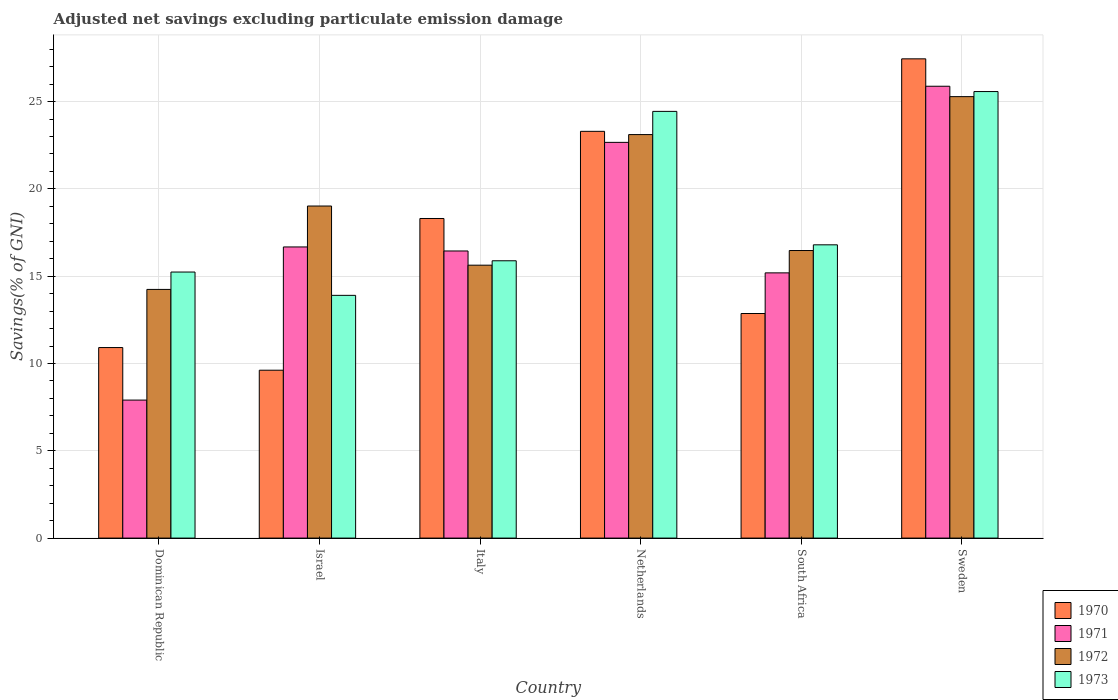How many different coloured bars are there?
Offer a very short reply. 4. Are the number of bars per tick equal to the number of legend labels?
Provide a short and direct response. Yes. How many bars are there on the 6th tick from the left?
Make the answer very short. 4. How many bars are there on the 3rd tick from the right?
Provide a short and direct response. 4. What is the adjusted net savings in 1971 in Italy?
Make the answer very short. 16.44. Across all countries, what is the maximum adjusted net savings in 1971?
Provide a succinct answer. 25.88. Across all countries, what is the minimum adjusted net savings in 1973?
Provide a short and direct response. 13.9. In which country was the adjusted net savings in 1971 minimum?
Offer a very short reply. Dominican Republic. What is the total adjusted net savings in 1970 in the graph?
Give a very brief answer. 102.44. What is the difference between the adjusted net savings in 1972 in Israel and that in Netherlands?
Provide a short and direct response. -4.09. What is the difference between the adjusted net savings in 1970 in South Africa and the adjusted net savings in 1971 in Italy?
Make the answer very short. -3.58. What is the average adjusted net savings in 1973 per country?
Provide a short and direct response. 18.64. What is the difference between the adjusted net savings of/in 1970 and adjusted net savings of/in 1973 in Israel?
Keep it short and to the point. -4.29. What is the ratio of the adjusted net savings in 1973 in Israel to that in Sweden?
Your answer should be very brief. 0.54. Is the adjusted net savings in 1973 in Netherlands less than that in Sweden?
Your answer should be compact. Yes. What is the difference between the highest and the second highest adjusted net savings in 1973?
Your response must be concise. -1.14. What is the difference between the highest and the lowest adjusted net savings in 1972?
Make the answer very short. 11.04. What does the 4th bar from the left in Israel represents?
Your answer should be very brief. 1973. What does the 3rd bar from the right in Netherlands represents?
Your answer should be very brief. 1971. How many bars are there?
Your answer should be very brief. 24. How many countries are there in the graph?
Provide a succinct answer. 6. Does the graph contain grids?
Offer a very short reply. Yes. How many legend labels are there?
Offer a very short reply. 4. What is the title of the graph?
Your answer should be compact. Adjusted net savings excluding particulate emission damage. What is the label or title of the Y-axis?
Your answer should be very brief. Savings(% of GNI). What is the Savings(% of GNI) in 1970 in Dominican Republic?
Ensure brevity in your answer.  10.91. What is the Savings(% of GNI) in 1971 in Dominican Republic?
Provide a succinct answer. 7.9. What is the Savings(% of GNI) in 1972 in Dominican Republic?
Provide a succinct answer. 14.24. What is the Savings(% of GNI) of 1973 in Dominican Republic?
Give a very brief answer. 15.24. What is the Savings(% of GNI) of 1970 in Israel?
Make the answer very short. 9.61. What is the Savings(% of GNI) in 1971 in Israel?
Your answer should be very brief. 16.67. What is the Savings(% of GNI) in 1972 in Israel?
Offer a terse response. 19.02. What is the Savings(% of GNI) in 1973 in Israel?
Give a very brief answer. 13.9. What is the Savings(% of GNI) in 1970 in Italy?
Your answer should be very brief. 18.3. What is the Savings(% of GNI) of 1971 in Italy?
Keep it short and to the point. 16.44. What is the Savings(% of GNI) of 1972 in Italy?
Provide a succinct answer. 15.63. What is the Savings(% of GNI) in 1973 in Italy?
Make the answer very short. 15.88. What is the Savings(% of GNI) of 1970 in Netherlands?
Give a very brief answer. 23.3. What is the Savings(% of GNI) in 1971 in Netherlands?
Make the answer very short. 22.66. What is the Savings(% of GNI) in 1972 in Netherlands?
Ensure brevity in your answer.  23.11. What is the Savings(% of GNI) in 1973 in Netherlands?
Your response must be concise. 24.44. What is the Savings(% of GNI) in 1970 in South Africa?
Provide a succinct answer. 12.86. What is the Savings(% of GNI) in 1971 in South Africa?
Keep it short and to the point. 15.19. What is the Savings(% of GNI) of 1972 in South Africa?
Give a very brief answer. 16.47. What is the Savings(% of GNI) in 1973 in South Africa?
Ensure brevity in your answer.  16.8. What is the Savings(% of GNI) in 1970 in Sweden?
Make the answer very short. 27.45. What is the Savings(% of GNI) in 1971 in Sweden?
Offer a terse response. 25.88. What is the Savings(% of GNI) in 1972 in Sweden?
Ensure brevity in your answer.  25.28. What is the Savings(% of GNI) in 1973 in Sweden?
Your answer should be very brief. 25.57. Across all countries, what is the maximum Savings(% of GNI) of 1970?
Make the answer very short. 27.45. Across all countries, what is the maximum Savings(% of GNI) in 1971?
Give a very brief answer. 25.88. Across all countries, what is the maximum Savings(% of GNI) in 1972?
Give a very brief answer. 25.28. Across all countries, what is the maximum Savings(% of GNI) of 1973?
Provide a short and direct response. 25.57. Across all countries, what is the minimum Savings(% of GNI) in 1970?
Give a very brief answer. 9.61. Across all countries, what is the minimum Savings(% of GNI) of 1971?
Your answer should be very brief. 7.9. Across all countries, what is the minimum Savings(% of GNI) in 1972?
Provide a short and direct response. 14.24. Across all countries, what is the minimum Savings(% of GNI) in 1973?
Your answer should be compact. 13.9. What is the total Savings(% of GNI) of 1970 in the graph?
Keep it short and to the point. 102.44. What is the total Savings(% of GNI) in 1971 in the graph?
Provide a short and direct response. 104.75. What is the total Savings(% of GNI) of 1972 in the graph?
Make the answer very short. 113.75. What is the total Savings(% of GNI) in 1973 in the graph?
Your answer should be compact. 111.83. What is the difference between the Savings(% of GNI) in 1970 in Dominican Republic and that in Israel?
Give a very brief answer. 1.3. What is the difference between the Savings(% of GNI) in 1971 in Dominican Republic and that in Israel?
Offer a very short reply. -8.77. What is the difference between the Savings(% of GNI) in 1972 in Dominican Republic and that in Israel?
Give a very brief answer. -4.78. What is the difference between the Savings(% of GNI) in 1973 in Dominican Republic and that in Israel?
Offer a very short reply. 1.34. What is the difference between the Savings(% of GNI) in 1970 in Dominican Republic and that in Italy?
Give a very brief answer. -7.39. What is the difference between the Savings(% of GNI) in 1971 in Dominican Republic and that in Italy?
Give a very brief answer. -8.54. What is the difference between the Savings(% of GNI) in 1972 in Dominican Republic and that in Italy?
Your response must be concise. -1.39. What is the difference between the Savings(% of GNI) of 1973 in Dominican Republic and that in Italy?
Offer a very short reply. -0.65. What is the difference between the Savings(% of GNI) in 1970 in Dominican Republic and that in Netherlands?
Your answer should be very brief. -12.38. What is the difference between the Savings(% of GNI) of 1971 in Dominican Republic and that in Netherlands?
Offer a very short reply. -14.76. What is the difference between the Savings(% of GNI) in 1972 in Dominican Republic and that in Netherlands?
Your answer should be compact. -8.87. What is the difference between the Savings(% of GNI) of 1973 in Dominican Republic and that in Netherlands?
Offer a terse response. -9.2. What is the difference between the Savings(% of GNI) of 1970 in Dominican Republic and that in South Africa?
Your answer should be compact. -1.95. What is the difference between the Savings(% of GNI) in 1971 in Dominican Republic and that in South Africa?
Provide a short and direct response. -7.29. What is the difference between the Savings(% of GNI) in 1972 in Dominican Republic and that in South Africa?
Offer a very short reply. -2.23. What is the difference between the Savings(% of GNI) in 1973 in Dominican Republic and that in South Africa?
Your response must be concise. -1.56. What is the difference between the Savings(% of GNI) in 1970 in Dominican Republic and that in Sweden?
Make the answer very short. -16.54. What is the difference between the Savings(% of GNI) in 1971 in Dominican Republic and that in Sweden?
Provide a short and direct response. -17.97. What is the difference between the Savings(% of GNI) of 1972 in Dominican Republic and that in Sweden?
Offer a very short reply. -11.04. What is the difference between the Savings(% of GNI) in 1973 in Dominican Republic and that in Sweden?
Provide a succinct answer. -10.34. What is the difference between the Savings(% of GNI) of 1970 in Israel and that in Italy?
Your answer should be very brief. -8.69. What is the difference between the Savings(% of GNI) of 1971 in Israel and that in Italy?
Your answer should be very brief. 0.23. What is the difference between the Savings(% of GNI) of 1972 in Israel and that in Italy?
Your answer should be very brief. 3.39. What is the difference between the Savings(% of GNI) in 1973 in Israel and that in Italy?
Offer a very short reply. -1.98. What is the difference between the Savings(% of GNI) of 1970 in Israel and that in Netherlands?
Offer a terse response. -13.68. What is the difference between the Savings(% of GNI) of 1971 in Israel and that in Netherlands?
Offer a terse response. -5.99. What is the difference between the Savings(% of GNI) of 1972 in Israel and that in Netherlands?
Your response must be concise. -4.09. What is the difference between the Savings(% of GNI) in 1973 in Israel and that in Netherlands?
Your response must be concise. -10.54. What is the difference between the Savings(% of GNI) of 1970 in Israel and that in South Africa?
Provide a short and direct response. -3.25. What is the difference between the Savings(% of GNI) of 1971 in Israel and that in South Africa?
Ensure brevity in your answer.  1.48. What is the difference between the Savings(% of GNI) in 1972 in Israel and that in South Africa?
Ensure brevity in your answer.  2.55. What is the difference between the Savings(% of GNI) in 1973 in Israel and that in South Africa?
Give a very brief answer. -2.89. What is the difference between the Savings(% of GNI) in 1970 in Israel and that in Sweden?
Keep it short and to the point. -17.83. What is the difference between the Savings(% of GNI) in 1971 in Israel and that in Sweden?
Offer a terse response. -9.2. What is the difference between the Savings(% of GNI) of 1972 in Israel and that in Sweden?
Your answer should be compact. -6.27. What is the difference between the Savings(% of GNI) in 1973 in Israel and that in Sweden?
Give a very brief answer. -11.67. What is the difference between the Savings(% of GNI) in 1970 in Italy and that in Netherlands?
Make the answer very short. -4.99. What is the difference between the Savings(% of GNI) in 1971 in Italy and that in Netherlands?
Ensure brevity in your answer.  -6.22. What is the difference between the Savings(% of GNI) of 1972 in Italy and that in Netherlands?
Ensure brevity in your answer.  -7.48. What is the difference between the Savings(% of GNI) in 1973 in Italy and that in Netherlands?
Your answer should be very brief. -8.56. What is the difference between the Savings(% of GNI) in 1970 in Italy and that in South Africa?
Keep it short and to the point. 5.44. What is the difference between the Savings(% of GNI) in 1971 in Italy and that in South Africa?
Keep it short and to the point. 1.25. What is the difference between the Savings(% of GNI) of 1972 in Italy and that in South Africa?
Your response must be concise. -0.84. What is the difference between the Savings(% of GNI) of 1973 in Italy and that in South Africa?
Your answer should be very brief. -0.91. What is the difference between the Savings(% of GNI) in 1970 in Italy and that in Sweden?
Ensure brevity in your answer.  -9.14. What is the difference between the Savings(% of GNI) in 1971 in Italy and that in Sweden?
Your answer should be compact. -9.43. What is the difference between the Savings(% of GNI) of 1972 in Italy and that in Sweden?
Your answer should be compact. -9.65. What is the difference between the Savings(% of GNI) in 1973 in Italy and that in Sweden?
Your response must be concise. -9.69. What is the difference between the Savings(% of GNI) in 1970 in Netherlands and that in South Africa?
Keep it short and to the point. 10.43. What is the difference between the Savings(% of GNI) in 1971 in Netherlands and that in South Africa?
Make the answer very short. 7.47. What is the difference between the Savings(% of GNI) of 1972 in Netherlands and that in South Africa?
Make the answer very short. 6.64. What is the difference between the Savings(% of GNI) of 1973 in Netherlands and that in South Africa?
Make the answer very short. 7.64. What is the difference between the Savings(% of GNI) in 1970 in Netherlands and that in Sweden?
Keep it short and to the point. -4.15. What is the difference between the Savings(% of GNI) in 1971 in Netherlands and that in Sweden?
Make the answer very short. -3.21. What is the difference between the Savings(% of GNI) of 1972 in Netherlands and that in Sweden?
Your answer should be very brief. -2.17. What is the difference between the Savings(% of GNI) in 1973 in Netherlands and that in Sweden?
Ensure brevity in your answer.  -1.14. What is the difference between the Savings(% of GNI) in 1970 in South Africa and that in Sweden?
Offer a very short reply. -14.59. What is the difference between the Savings(% of GNI) of 1971 in South Africa and that in Sweden?
Provide a short and direct response. -10.69. What is the difference between the Savings(% of GNI) in 1972 in South Africa and that in Sweden?
Give a very brief answer. -8.81. What is the difference between the Savings(% of GNI) in 1973 in South Africa and that in Sweden?
Your answer should be very brief. -8.78. What is the difference between the Savings(% of GNI) in 1970 in Dominican Republic and the Savings(% of GNI) in 1971 in Israel?
Your answer should be very brief. -5.76. What is the difference between the Savings(% of GNI) in 1970 in Dominican Republic and the Savings(% of GNI) in 1972 in Israel?
Offer a very short reply. -8.11. What is the difference between the Savings(% of GNI) of 1970 in Dominican Republic and the Savings(% of GNI) of 1973 in Israel?
Provide a short and direct response. -2.99. What is the difference between the Savings(% of GNI) in 1971 in Dominican Republic and the Savings(% of GNI) in 1972 in Israel?
Make the answer very short. -11.11. What is the difference between the Savings(% of GNI) of 1971 in Dominican Republic and the Savings(% of GNI) of 1973 in Israel?
Keep it short and to the point. -6. What is the difference between the Savings(% of GNI) of 1972 in Dominican Republic and the Savings(% of GNI) of 1973 in Israel?
Your answer should be very brief. 0.34. What is the difference between the Savings(% of GNI) of 1970 in Dominican Republic and the Savings(% of GNI) of 1971 in Italy?
Keep it short and to the point. -5.53. What is the difference between the Savings(% of GNI) of 1970 in Dominican Republic and the Savings(% of GNI) of 1972 in Italy?
Keep it short and to the point. -4.72. What is the difference between the Savings(% of GNI) of 1970 in Dominican Republic and the Savings(% of GNI) of 1973 in Italy?
Ensure brevity in your answer.  -4.97. What is the difference between the Savings(% of GNI) of 1971 in Dominican Republic and the Savings(% of GNI) of 1972 in Italy?
Provide a succinct answer. -7.73. What is the difference between the Savings(% of GNI) in 1971 in Dominican Republic and the Savings(% of GNI) in 1973 in Italy?
Ensure brevity in your answer.  -7.98. What is the difference between the Savings(% of GNI) of 1972 in Dominican Republic and the Savings(% of GNI) of 1973 in Italy?
Your response must be concise. -1.64. What is the difference between the Savings(% of GNI) of 1970 in Dominican Republic and the Savings(% of GNI) of 1971 in Netherlands?
Offer a terse response. -11.75. What is the difference between the Savings(% of GNI) in 1970 in Dominican Republic and the Savings(% of GNI) in 1972 in Netherlands?
Provide a succinct answer. -12.2. What is the difference between the Savings(% of GNI) in 1970 in Dominican Republic and the Savings(% of GNI) in 1973 in Netherlands?
Make the answer very short. -13.53. What is the difference between the Savings(% of GNI) in 1971 in Dominican Republic and the Savings(% of GNI) in 1972 in Netherlands?
Give a very brief answer. -15.21. What is the difference between the Savings(% of GNI) in 1971 in Dominican Republic and the Savings(% of GNI) in 1973 in Netherlands?
Provide a short and direct response. -16.53. What is the difference between the Savings(% of GNI) in 1972 in Dominican Republic and the Savings(% of GNI) in 1973 in Netherlands?
Keep it short and to the point. -10.2. What is the difference between the Savings(% of GNI) of 1970 in Dominican Republic and the Savings(% of GNI) of 1971 in South Africa?
Ensure brevity in your answer.  -4.28. What is the difference between the Savings(% of GNI) in 1970 in Dominican Republic and the Savings(% of GNI) in 1972 in South Africa?
Give a very brief answer. -5.56. What is the difference between the Savings(% of GNI) in 1970 in Dominican Republic and the Savings(% of GNI) in 1973 in South Africa?
Offer a very short reply. -5.88. What is the difference between the Savings(% of GNI) of 1971 in Dominican Republic and the Savings(% of GNI) of 1972 in South Africa?
Provide a short and direct response. -8.57. What is the difference between the Savings(% of GNI) of 1971 in Dominican Republic and the Savings(% of GNI) of 1973 in South Africa?
Your answer should be very brief. -8.89. What is the difference between the Savings(% of GNI) in 1972 in Dominican Republic and the Savings(% of GNI) in 1973 in South Africa?
Make the answer very short. -2.55. What is the difference between the Savings(% of GNI) of 1970 in Dominican Republic and the Savings(% of GNI) of 1971 in Sweden?
Make the answer very short. -14.97. What is the difference between the Savings(% of GNI) in 1970 in Dominican Republic and the Savings(% of GNI) in 1972 in Sweden?
Ensure brevity in your answer.  -14.37. What is the difference between the Savings(% of GNI) of 1970 in Dominican Republic and the Savings(% of GNI) of 1973 in Sweden?
Your answer should be very brief. -14.66. What is the difference between the Savings(% of GNI) in 1971 in Dominican Republic and the Savings(% of GNI) in 1972 in Sweden?
Make the answer very short. -17.38. What is the difference between the Savings(% of GNI) of 1971 in Dominican Republic and the Savings(% of GNI) of 1973 in Sweden?
Ensure brevity in your answer.  -17.67. What is the difference between the Savings(% of GNI) of 1972 in Dominican Republic and the Savings(% of GNI) of 1973 in Sweden?
Provide a succinct answer. -11.33. What is the difference between the Savings(% of GNI) in 1970 in Israel and the Savings(% of GNI) in 1971 in Italy?
Offer a terse response. -6.83. What is the difference between the Savings(% of GNI) in 1970 in Israel and the Savings(% of GNI) in 1972 in Italy?
Provide a short and direct response. -6.02. What is the difference between the Savings(% of GNI) of 1970 in Israel and the Savings(% of GNI) of 1973 in Italy?
Make the answer very short. -6.27. What is the difference between the Savings(% of GNI) in 1971 in Israel and the Savings(% of GNI) in 1972 in Italy?
Offer a terse response. 1.04. What is the difference between the Savings(% of GNI) of 1971 in Israel and the Savings(% of GNI) of 1973 in Italy?
Provide a short and direct response. 0.79. What is the difference between the Savings(% of GNI) in 1972 in Israel and the Savings(% of GNI) in 1973 in Italy?
Make the answer very short. 3.14. What is the difference between the Savings(% of GNI) of 1970 in Israel and the Savings(% of GNI) of 1971 in Netherlands?
Offer a terse response. -13.05. What is the difference between the Savings(% of GNI) in 1970 in Israel and the Savings(% of GNI) in 1972 in Netherlands?
Provide a short and direct response. -13.49. What is the difference between the Savings(% of GNI) in 1970 in Israel and the Savings(% of GNI) in 1973 in Netherlands?
Provide a short and direct response. -14.82. What is the difference between the Savings(% of GNI) of 1971 in Israel and the Savings(% of GNI) of 1972 in Netherlands?
Ensure brevity in your answer.  -6.44. What is the difference between the Savings(% of GNI) of 1971 in Israel and the Savings(% of GNI) of 1973 in Netherlands?
Your response must be concise. -7.76. What is the difference between the Savings(% of GNI) of 1972 in Israel and the Savings(% of GNI) of 1973 in Netherlands?
Your answer should be compact. -5.42. What is the difference between the Savings(% of GNI) of 1970 in Israel and the Savings(% of GNI) of 1971 in South Africa?
Offer a terse response. -5.58. What is the difference between the Savings(% of GNI) in 1970 in Israel and the Savings(% of GNI) in 1972 in South Africa?
Ensure brevity in your answer.  -6.86. What is the difference between the Savings(% of GNI) in 1970 in Israel and the Savings(% of GNI) in 1973 in South Africa?
Your answer should be very brief. -7.18. What is the difference between the Savings(% of GNI) of 1971 in Israel and the Savings(% of GNI) of 1972 in South Africa?
Offer a very short reply. 0.2. What is the difference between the Savings(% of GNI) of 1971 in Israel and the Savings(% of GNI) of 1973 in South Africa?
Your answer should be compact. -0.12. What is the difference between the Savings(% of GNI) in 1972 in Israel and the Savings(% of GNI) in 1973 in South Africa?
Keep it short and to the point. 2.22. What is the difference between the Savings(% of GNI) in 1970 in Israel and the Savings(% of GNI) in 1971 in Sweden?
Provide a succinct answer. -16.26. What is the difference between the Savings(% of GNI) of 1970 in Israel and the Savings(% of GNI) of 1972 in Sweden?
Your answer should be very brief. -15.67. What is the difference between the Savings(% of GNI) in 1970 in Israel and the Savings(% of GNI) in 1973 in Sweden?
Provide a short and direct response. -15.96. What is the difference between the Savings(% of GNI) of 1971 in Israel and the Savings(% of GNI) of 1972 in Sweden?
Keep it short and to the point. -8.61. What is the difference between the Savings(% of GNI) in 1971 in Israel and the Savings(% of GNI) in 1973 in Sweden?
Make the answer very short. -8.9. What is the difference between the Savings(% of GNI) of 1972 in Israel and the Savings(% of GNI) of 1973 in Sweden?
Ensure brevity in your answer.  -6.56. What is the difference between the Savings(% of GNI) in 1970 in Italy and the Savings(% of GNI) in 1971 in Netherlands?
Offer a terse response. -4.36. What is the difference between the Savings(% of GNI) of 1970 in Italy and the Savings(% of GNI) of 1972 in Netherlands?
Your response must be concise. -4.81. What is the difference between the Savings(% of GNI) in 1970 in Italy and the Savings(% of GNI) in 1973 in Netherlands?
Your answer should be very brief. -6.13. What is the difference between the Savings(% of GNI) in 1971 in Italy and the Savings(% of GNI) in 1972 in Netherlands?
Ensure brevity in your answer.  -6.67. What is the difference between the Savings(% of GNI) of 1971 in Italy and the Savings(% of GNI) of 1973 in Netherlands?
Provide a succinct answer. -7.99. What is the difference between the Savings(% of GNI) in 1972 in Italy and the Savings(% of GNI) in 1973 in Netherlands?
Ensure brevity in your answer.  -8.81. What is the difference between the Savings(% of GNI) in 1970 in Italy and the Savings(% of GNI) in 1971 in South Africa?
Your response must be concise. 3.11. What is the difference between the Savings(% of GNI) of 1970 in Italy and the Savings(% of GNI) of 1972 in South Africa?
Provide a succinct answer. 1.83. What is the difference between the Savings(% of GNI) of 1970 in Italy and the Savings(% of GNI) of 1973 in South Africa?
Make the answer very short. 1.51. What is the difference between the Savings(% of GNI) of 1971 in Italy and the Savings(% of GNI) of 1972 in South Africa?
Your answer should be very brief. -0.03. What is the difference between the Savings(% of GNI) in 1971 in Italy and the Savings(% of GNI) in 1973 in South Africa?
Your answer should be very brief. -0.35. What is the difference between the Savings(% of GNI) of 1972 in Italy and the Savings(% of GNI) of 1973 in South Africa?
Offer a very short reply. -1.17. What is the difference between the Savings(% of GNI) of 1970 in Italy and the Savings(% of GNI) of 1971 in Sweden?
Offer a terse response. -7.57. What is the difference between the Savings(% of GNI) of 1970 in Italy and the Savings(% of GNI) of 1972 in Sweden?
Make the answer very short. -6.98. What is the difference between the Savings(% of GNI) of 1970 in Italy and the Savings(% of GNI) of 1973 in Sweden?
Provide a short and direct response. -7.27. What is the difference between the Savings(% of GNI) of 1971 in Italy and the Savings(% of GNI) of 1972 in Sweden?
Make the answer very short. -8.84. What is the difference between the Savings(% of GNI) of 1971 in Italy and the Savings(% of GNI) of 1973 in Sweden?
Make the answer very short. -9.13. What is the difference between the Savings(% of GNI) in 1972 in Italy and the Savings(% of GNI) in 1973 in Sweden?
Your answer should be compact. -9.94. What is the difference between the Savings(% of GNI) in 1970 in Netherlands and the Savings(% of GNI) in 1971 in South Africa?
Provide a succinct answer. 8.11. What is the difference between the Savings(% of GNI) in 1970 in Netherlands and the Savings(% of GNI) in 1972 in South Africa?
Give a very brief answer. 6.83. What is the difference between the Savings(% of GNI) in 1970 in Netherlands and the Savings(% of GNI) in 1973 in South Africa?
Provide a short and direct response. 6.5. What is the difference between the Savings(% of GNI) of 1971 in Netherlands and the Savings(% of GNI) of 1972 in South Africa?
Your response must be concise. 6.19. What is the difference between the Savings(% of GNI) of 1971 in Netherlands and the Savings(% of GNI) of 1973 in South Africa?
Ensure brevity in your answer.  5.87. What is the difference between the Savings(% of GNI) in 1972 in Netherlands and the Savings(% of GNI) in 1973 in South Africa?
Give a very brief answer. 6.31. What is the difference between the Savings(% of GNI) in 1970 in Netherlands and the Savings(% of GNI) in 1971 in Sweden?
Offer a very short reply. -2.58. What is the difference between the Savings(% of GNI) of 1970 in Netherlands and the Savings(% of GNI) of 1972 in Sweden?
Ensure brevity in your answer.  -1.99. What is the difference between the Savings(% of GNI) in 1970 in Netherlands and the Savings(% of GNI) in 1973 in Sweden?
Make the answer very short. -2.28. What is the difference between the Savings(% of GNI) in 1971 in Netherlands and the Savings(% of GNI) in 1972 in Sweden?
Your answer should be compact. -2.62. What is the difference between the Savings(% of GNI) in 1971 in Netherlands and the Savings(% of GNI) in 1973 in Sweden?
Offer a terse response. -2.91. What is the difference between the Savings(% of GNI) in 1972 in Netherlands and the Savings(% of GNI) in 1973 in Sweden?
Your answer should be compact. -2.46. What is the difference between the Savings(% of GNI) in 1970 in South Africa and the Savings(% of GNI) in 1971 in Sweden?
Your response must be concise. -13.02. What is the difference between the Savings(% of GNI) of 1970 in South Africa and the Savings(% of GNI) of 1972 in Sweden?
Your response must be concise. -12.42. What is the difference between the Savings(% of GNI) in 1970 in South Africa and the Savings(% of GNI) in 1973 in Sweden?
Provide a succinct answer. -12.71. What is the difference between the Savings(% of GNI) of 1971 in South Africa and the Savings(% of GNI) of 1972 in Sweden?
Ensure brevity in your answer.  -10.09. What is the difference between the Savings(% of GNI) of 1971 in South Africa and the Savings(% of GNI) of 1973 in Sweden?
Ensure brevity in your answer.  -10.38. What is the difference between the Savings(% of GNI) in 1972 in South Africa and the Savings(% of GNI) in 1973 in Sweden?
Your response must be concise. -9.1. What is the average Savings(% of GNI) in 1970 per country?
Your response must be concise. 17.07. What is the average Savings(% of GNI) in 1971 per country?
Offer a terse response. 17.46. What is the average Savings(% of GNI) of 1972 per country?
Provide a short and direct response. 18.96. What is the average Savings(% of GNI) in 1973 per country?
Ensure brevity in your answer.  18.64. What is the difference between the Savings(% of GNI) of 1970 and Savings(% of GNI) of 1971 in Dominican Republic?
Ensure brevity in your answer.  3.01. What is the difference between the Savings(% of GNI) in 1970 and Savings(% of GNI) in 1972 in Dominican Republic?
Give a very brief answer. -3.33. What is the difference between the Savings(% of GNI) of 1970 and Savings(% of GNI) of 1973 in Dominican Republic?
Keep it short and to the point. -4.33. What is the difference between the Savings(% of GNI) in 1971 and Savings(% of GNI) in 1972 in Dominican Republic?
Your answer should be very brief. -6.34. What is the difference between the Savings(% of GNI) in 1971 and Savings(% of GNI) in 1973 in Dominican Republic?
Your response must be concise. -7.33. What is the difference between the Savings(% of GNI) in 1972 and Savings(% of GNI) in 1973 in Dominican Republic?
Give a very brief answer. -1. What is the difference between the Savings(% of GNI) in 1970 and Savings(% of GNI) in 1971 in Israel?
Your answer should be very brief. -7.06. What is the difference between the Savings(% of GNI) of 1970 and Savings(% of GNI) of 1972 in Israel?
Offer a very short reply. -9.4. What is the difference between the Savings(% of GNI) in 1970 and Savings(% of GNI) in 1973 in Israel?
Ensure brevity in your answer.  -4.29. What is the difference between the Savings(% of GNI) of 1971 and Savings(% of GNI) of 1972 in Israel?
Offer a very short reply. -2.34. What is the difference between the Savings(% of GNI) in 1971 and Savings(% of GNI) in 1973 in Israel?
Provide a succinct answer. 2.77. What is the difference between the Savings(% of GNI) in 1972 and Savings(% of GNI) in 1973 in Israel?
Keep it short and to the point. 5.12. What is the difference between the Savings(% of GNI) of 1970 and Savings(% of GNI) of 1971 in Italy?
Your response must be concise. 1.86. What is the difference between the Savings(% of GNI) of 1970 and Savings(% of GNI) of 1972 in Italy?
Your answer should be compact. 2.67. What is the difference between the Savings(% of GNI) of 1970 and Savings(% of GNI) of 1973 in Italy?
Offer a very short reply. 2.42. What is the difference between the Savings(% of GNI) in 1971 and Savings(% of GNI) in 1972 in Italy?
Offer a very short reply. 0.81. What is the difference between the Savings(% of GNI) in 1971 and Savings(% of GNI) in 1973 in Italy?
Provide a short and direct response. 0.56. What is the difference between the Savings(% of GNI) of 1972 and Savings(% of GNI) of 1973 in Italy?
Offer a terse response. -0.25. What is the difference between the Savings(% of GNI) of 1970 and Savings(% of GNI) of 1971 in Netherlands?
Ensure brevity in your answer.  0.63. What is the difference between the Savings(% of GNI) in 1970 and Savings(% of GNI) in 1972 in Netherlands?
Give a very brief answer. 0.19. What is the difference between the Savings(% of GNI) of 1970 and Savings(% of GNI) of 1973 in Netherlands?
Your response must be concise. -1.14. What is the difference between the Savings(% of GNI) of 1971 and Savings(% of GNI) of 1972 in Netherlands?
Give a very brief answer. -0.45. What is the difference between the Savings(% of GNI) in 1971 and Savings(% of GNI) in 1973 in Netherlands?
Your answer should be compact. -1.77. What is the difference between the Savings(% of GNI) of 1972 and Savings(% of GNI) of 1973 in Netherlands?
Keep it short and to the point. -1.33. What is the difference between the Savings(% of GNI) of 1970 and Savings(% of GNI) of 1971 in South Africa?
Keep it short and to the point. -2.33. What is the difference between the Savings(% of GNI) in 1970 and Savings(% of GNI) in 1972 in South Africa?
Your answer should be compact. -3.61. What is the difference between the Savings(% of GNI) in 1970 and Savings(% of GNI) in 1973 in South Africa?
Offer a very short reply. -3.93. What is the difference between the Savings(% of GNI) of 1971 and Savings(% of GNI) of 1972 in South Africa?
Keep it short and to the point. -1.28. What is the difference between the Savings(% of GNI) in 1971 and Savings(% of GNI) in 1973 in South Africa?
Your answer should be very brief. -1.61. What is the difference between the Savings(% of GNI) of 1972 and Savings(% of GNI) of 1973 in South Africa?
Keep it short and to the point. -0.33. What is the difference between the Savings(% of GNI) in 1970 and Savings(% of GNI) in 1971 in Sweden?
Offer a terse response. 1.57. What is the difference between the Savings(% of GNI) in 1970 and Savings(% of GNI) in 1972 in Sweden?
Provide a succinct answer. 2.16. What is the difference between the Savings(% of GNI) in 1970 and Savings(% of GNI) in 1973 in Sweden?
Offer a very short reply. 1.87. What is the difference between the Savings(% of GNI) of 1971 and Savings(% of GNI) of 1972 in Sweden?
Provide a succinct answer. 0.59. What is the difference between the Savings(% of GNI) of 1971 and Savings(% of GNI) of 1973 in Sweden?
Your answer should be compact. 0.3. What is the difference between the Savings(% of GNI) of 1972 and Savings(% of GNI) of 1973 in Sweden?
Keep it short and to the point. -0.29. What is the ratio of the Savings(% of GNI) in 1970 in Dominican Republic to that in Israel?
Offer a very short reply. 1.14. What is the ratio of the Savings(% of GNI) in 1971 in Dominican Republic to that in Israel?
Offer a very short reply. 0.47. What is the ratio of the Savings(% of GNI) of 1972 in Dominican Republic to that in Israel?
Make the answer very short. 0.75. What is the ratio of the Savings(% of GNI) in 1973 in Dominican Republic to that in Israel?
Your answer should be very brief. 1.1. What is the ratio of the Savings(% of GNI) in 1970 in Dominican Republic to that in Italy?
Offer a very short reply. 0.6. What is the ratio of the Savings(% of GNI) in 1971 in Dominican Republic to that in Italy?
Provide a short and direct response. 0.48. What is the ratio of the Savings(% of GNI) of 1972 in Dominican Republic to that in Italy?
Keep it short and to the point. 0.91. What is the ratio of the Savings(% of GNI) of 1973 in Dominican Republic to that in Italy?
Offer a very short reply. 0.96. What is the ratio of the Savings(% of GNI) in 1970 in Dominican Republic to that in Netherlands?
Give a very brief answer. 0.47. What is the ratio of the Savings(% of GNI) of 1971 in Dominican Republic to that in Netherlands?
Make the answer very short. 0.35. What is the ratio of the Savings(% of GNI) of 1972 in Dominican Republic to that in Netherlands?
Your answer should be very brief. 0.62. What is the ratio of the Savings(% of GNI) of 1973 in Dominican Republic to that in Netherlands?
Offer a terse response. 0.62. What is the ratio of the Savings(% of GNI) in 1970 in Dominican Republic to that in South Africa?
Offer a terse response. 0.85. What is the ratio of the Savings(% of GNI) of 1971 in Dominican Republic to that in South Africa?
Ensure brevity in your answer.  0.52. What is the ratio of the Savings(% of GNI) in 1972 in Dominican Republic to that in South Africa?
Keep it short and to the point. 0.86. What is the ratio of the Savings(% of GNI) in 1973 in Dominican Republic to that in South Africa?
Provide a succinct answer. 0.91. What is the ratio of the Savings(% of GNI) of 1970 in Dominican Republic to that in Sweden?
Give a very brief answer. 0.4. What is the ratio of the Savings(% of GNI) of 1971 in Dominican Republic to that in Sweden?
Ensure brevity in your answer.  0.31. What is the ratio of the Savings(% of GNI) in 1972 in Dominican Republic to that in Sweden?
Provide a succinct answer. 0.56. What is the ratio of the Savings(% of GNI) of 1973 in Dominican Republic to that in Sweden?
Your answer should be very brief. 0.6. What is the ratio of the Savings(% of GNI) in 1970 in Israel to that in Italy?
Ensure brevity in your answer.  0.53. What is the ratio of the Savings(% of GNI) of 1971 in Israel to that in Italy?
Provide a succinct answer. 1.01. What is the ratio of the Savings(% of GNI) of 1972 in Israel to that in Italy?
Offer a terse response. 1.22. What is the ratio of the Savings(% of GNI) of 1973 in Israel to that in Italy?
Make the answer very short. 0.88. What is the ratio of the Savings(% of GNI) in 1970 in Israel to that in Netherlands?
Offer a terse response. 0.41. What is the ratio of the Savings(% of GNI) in 1971 in Israel to that in Netherlands?
Your answer should be compact. 0.74. What is the ratio of the Savings(% of GNI) of 1972 in Israel to that in Netherlands?
Provide a succinct answer. 0.82. What is the ratio of the Savings(% of GNI) in 1973 in Israel to that in Netherlands?
Keep it short and to the point. 0.57. What is the ratio of the Savings(% of GNI) in 1970 in Israel to that in South Africa?
Provide a succinct answer. 0.75. What is the ratio of the Savings(% of GNI) in 1971 in Israel to that in South Africa?
Your answer should be compact. 1.1. What is the ratio of the Savings(% of GNI) in 1972 in Israel to that in South Africa?
Offer a terse response. 1.15. What is the ratio of the Savings(% of GNI) of 1973 in Israel to that in South Africa?
Offer a very short reply. 0.83. What is the ratio of the Savings(% of GNI) in 1970 in Israel to that in Sweden?
Your answer should be compact. 0.35. What is the ratio of the Savings(% of GNI) of 1971 in Israel to that in Sweden?
Keep it short and to the point. 0.64. What is the ratio of the Savings(% of GNI) in 1972 in Israel to that in Sweden?
Give a very brief answer. 0.75. What is the ratio of the Savings(% of GNI) of 1973 in Israel to that in Sweden?
Your response must be concise. 0.54. What is the ratio of the Savings(% of GNI) in 1970 in Italy to that in Netherlands?
Offer a very short reply. 0.79. What is the ratio of the Savings(% of GNI) in 1971 in Italy to that in Netherlands?
Offer a very short reply. 0.73. What is the ratio of the Savings(% of GNI) in 1972 in Italy to that in Netherlands?
Offer a terse response. 0.68. What is the ratio of the Savings(% of GNI) of 1973 in Italy to that in Netherlands?
Your response must be concise. 0.65. What is the ratio of the Savings(% of GNI) in 1970 in Italy to that in South Africa?
Your answer should be compact. 1.42. What is the ratio of the Savings(% of GNI) of 1971 in Italy to that in South Africa?
Your answer should be very brief. 1.08. What is the ratio of the Savings(% of GNI) of 1972 in Italy to that in South Africa?
Provide a short and direct response. 0.95. What is the ratio of the Savings(% of GNI) in 1973 in Italy to that in South Africa?
Your answer should be very brief. 0.95. What is the ratio of the Savings(% of GNI) in 1970 in Italy to that in Sweden?
Your response must be concise. 0.67. What is the ratio of the Savings(% of GNI) of 1971 in Italy to that in Sweden?
Your answer should be very brief. 0.64. What is the ratio of the Savings(% of GNI) in 1972 in Italy to that in Sweden?
Ensure brevity in your answer.  0.62. What is the ratio of the Savings(% of GNI) of 1973 in Italy to that in Sweden?
Provide a short and direct response. 0.62. What is the ratio of the Savings(% of GNI) of 1970 in Netherlands to that in South Africa?
Offer a very short reply. 1.81. What is the ratio of the Savings(% of GNI) in 1971 in Netherlands to that in South Africa?
Keep it short and to the point. 1.49. What is the ratio of the Savings(% of GNI) of 1972 in Netherlands to that in South Africa?
Give a very brief answer. 1.4. What is the ratio of the Savings(% of GNI) in 1973 in Netherlands to that in South Africa?
Ensure brevity in your answer.  1.46. What is the ratio of the Savings(% of GNI) in 1970 in Netherlands to that in Sweden?
Your response must be concise. 0.85. What is the ratio of the Savings(% of GNI) in 1971 in Netherlands to that in Sweden?
Keep it short and to the point. 0.88. What is the ratio of the Savings(% of GNI) of 1972 in Netherlands to that in Sweden?
Your response must be concise. 0.91. What is the ratio of the Savings(% of GNI) of 1973 in Netherlands to that in Sweden?
Ensure brevity in your answer.  0.96. What is the ratio of the Savings(% of GNI) of 1970 in South Africa to that in Sweden?
Offer a very short reply. 0.47. What is the ratio of the Savings(% of GNI) of 1971 in South Africa to that in Sweden?
Make the answer very short. 0.59. What is the ratio of the Savings(% of GNI) of 1972 in South Africa to that in Sweden?
Keep it short and to the point. 0.65. What is the ratio of the Savings(% of GNI) of 1973 in South Africa to that in Sweden?
Provide a succinct answer. 0.66. What is the difference between the highest and the second highest Savings(% of GNI) in 1970?
Offer a terse response. 4.15. What is the difference between the highest and the second highest Savings(% of GNI) in 1971?
Offer a very short reply. 3.21. What is the difference between the highest and the second highest Savings(% of GNI) in 1972?
Keep it short and to the point. 2.17. What is the difference between the highest and the second highest Savings(% of GNI) of 1973?
Keep it short and to the point. 1.14. What is the difference between the highest and the lowest Savings(% of GNI) of 1970?
Offer a terse response. 17.83. What is the difference between the highest and the lowest Savings(% of GNI) in 1971?
Provide a succinct answer. 17.97. What is the difference between the highest and the lowest Savings(% of GNI) of 1972?
Provide a short and direct response. 11.04. What is the difference between the highest and the lowest Savings(% of GNI) in 1973?
Your answer should be very brief. 11.67. 